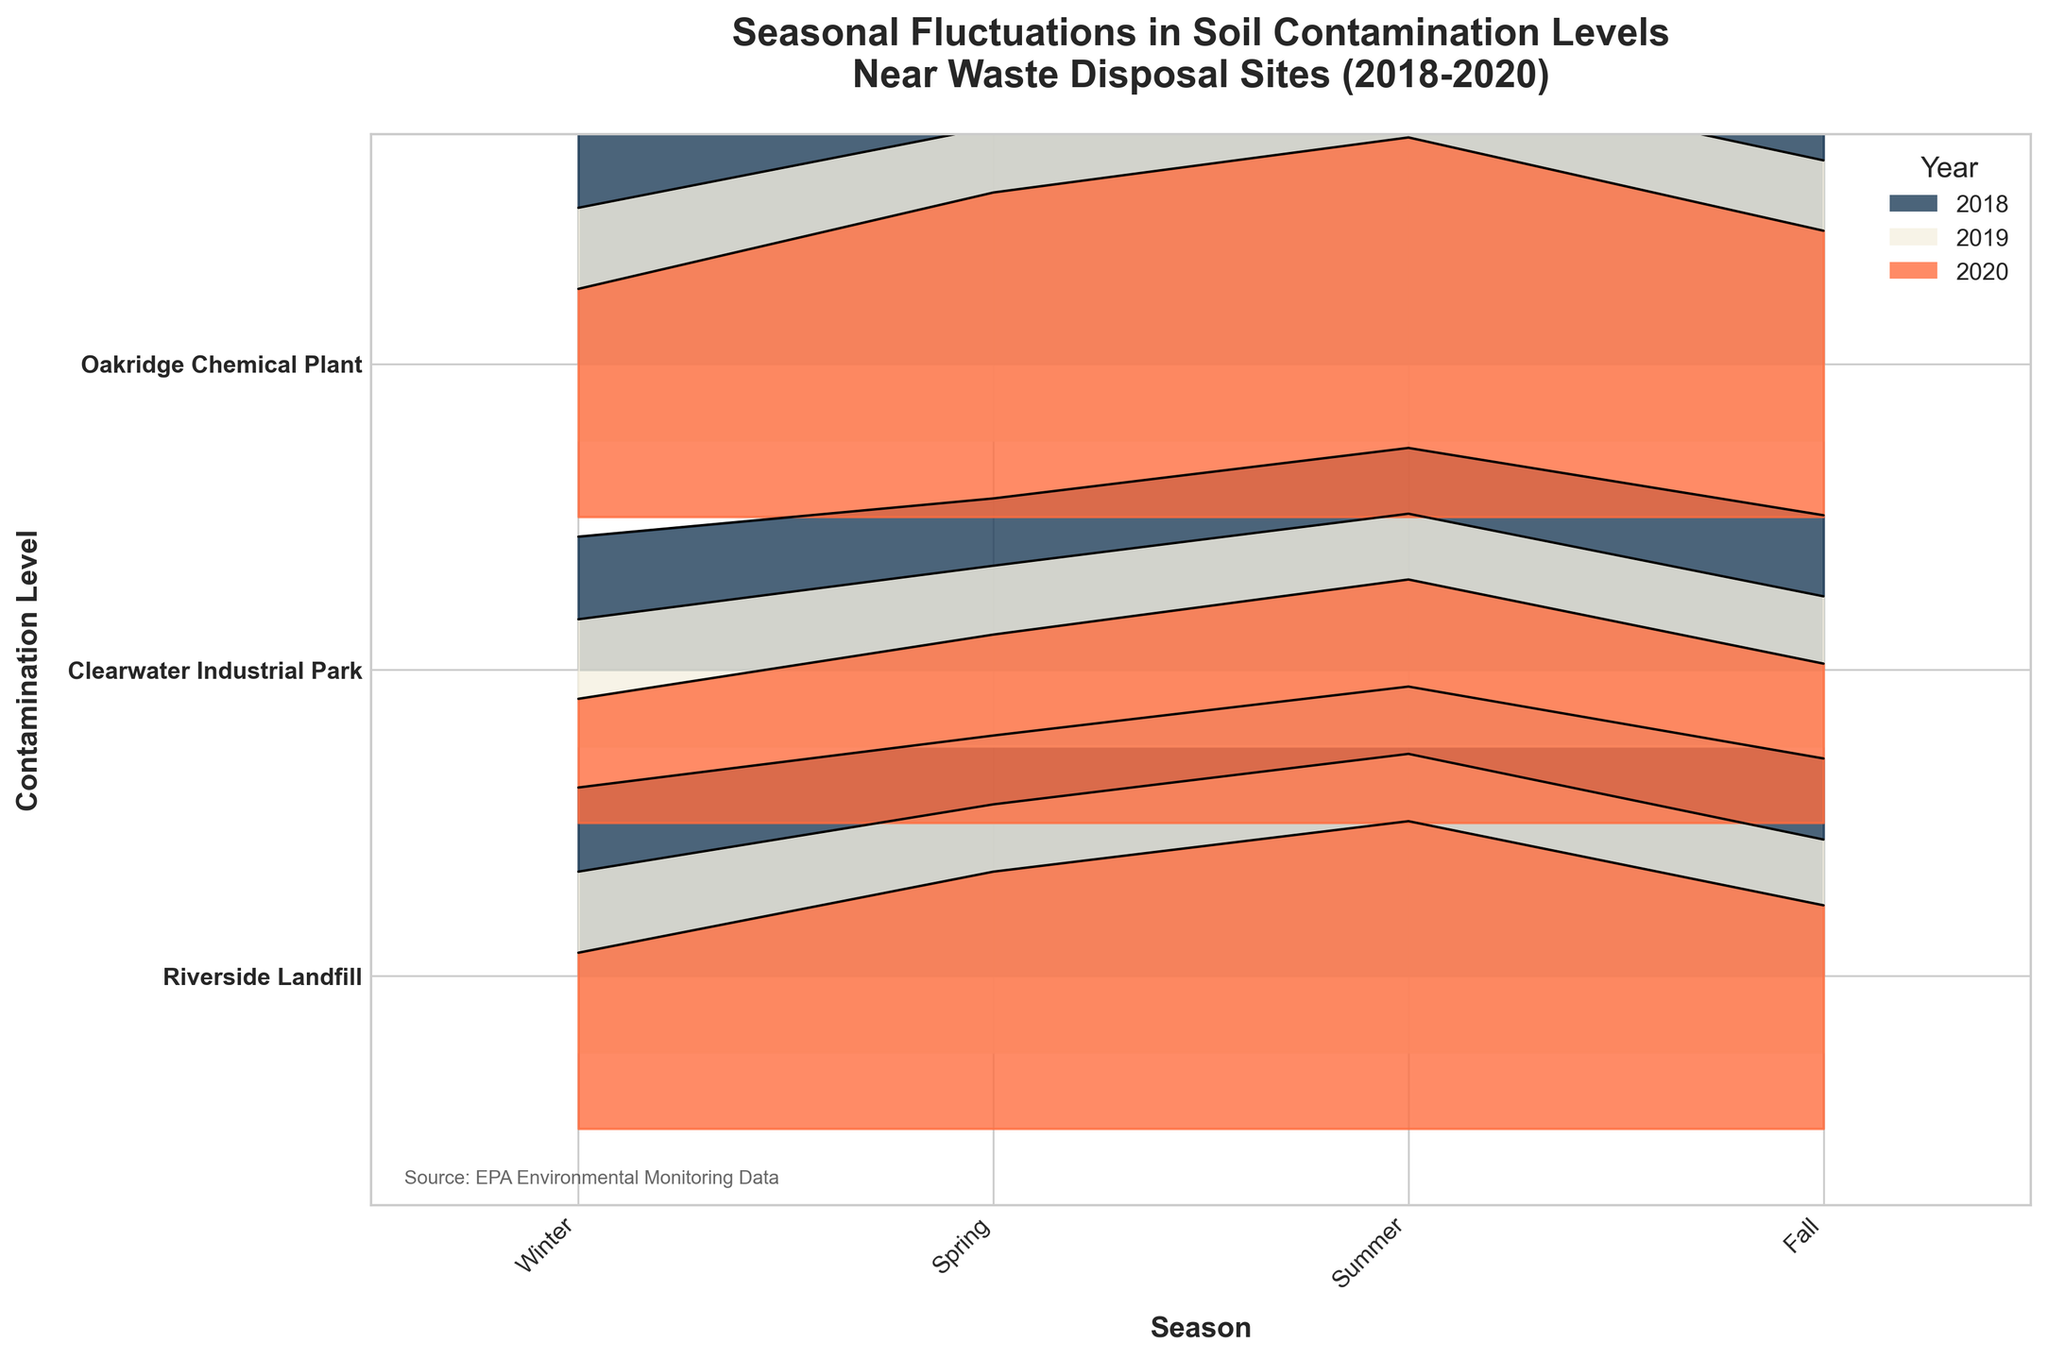What's the title of the figure? The title is displayed at the top of the figure. It reads "Seasonal Fluctuations in Soil Contamination Levels Near Waste Disposal Sites (2018-2020)".
Answer: Seasonal Fluctuations in Soil Contamination Levels Near Waste Disposal Sites (2018-2020) Which site had the highest contamination level in Summer 2020? To answer this, look at the Summer 2020 data for all three sites. The site with the highest line or filled area in Summer 2020 is Oakridge Chemical Plant.
Answer: Oakridge Chemical Plant How do contamination levels in Riverside Landfill compare across seasons for the year 2019? Analyze the 2019 data for Riverside Landfill. The contamination levels are Winter: 11.8, Spring: 16.2, Summer: 19.5, and Fall: 13.9.
Answer: Winter: 11.8, Spring: 16.2, Summer: 19.5, Fall: 13.9 Which year had the most significant seasonal fluctuation in contamination levels for Clearwater Industrial Park? Compare the differences in contamination levels among seasons for each year at Clearwater Industrial Park. The largest fluctuating year will have the widest range between the highest and lowest points. Year 2019 varies from 8.3 in Winter to 15.2 in Summer.
Answer: 2019 Are contamination levels generally higher in Summer or Winter at Oakridge Chemical Plant? Compare the contamination levels for Summer and Winter across all years at Oakridge Chemical Plant; notice that Summer values (23.4, 24.1, 24.8) are consistently higher than Winter values (15.6, 15.2, 14.9).
Answer: Summer What trends can be observed in contamination levels at Riverside Landfill from 2018 to 2020? Analyze the lines or filled areas across the years for Riverside Landfill. Data shows a stable fluctuation pattern where Summer has the highest and Winter the lowest across all years, with slight overall increase over three years.
Answer: Stable fluctuation, slight increase What's the average contamination level in Fall for Oakridge Chemical Plant over 2018-2020? To find the average, add Fall values for 2018 (17.9), 2019 (18.3), and 2020 (18.7), then divide by 3: (17.9 + 18.3 + 18.7) / 3 = 18.3.
Answer: 18.3 Compare the fluctuation range (highest minus lowest) of contamination levels across seasons in 2020 for all three sites. Compute the difference between highest and lowest values for each site in 2020: Riverside Landfill: 20.1 - 11.5 = 8.6, Clearwater Industrial Park: 15.9 - 8.1 = 7.8, Oakridge Chemical Plant: 24.8 - 14.9 = 9.9.
Answer: Riverside Landfill: 8.6, Clearwater Industrial Park: 7.8, Oakridge Chemical Plant: 9.9 What is the pattern of contamination level changes from Spring to Summer across all sites in 2019? Check the data for Spring to Summer transition in 2019 for each site: Riverside Landfill increases from 16.2 to 19.5, Clearwater Industrial Park increases from 11.8 to 15.2, Oakridge Chemical Plant increases from 20.5 to 24.1. All sites show an increase.
Answer: Increase at all sites 